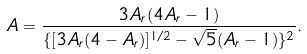<formula> <loc_0><loc_0><loc_500><loc_500>A = \frac { 3 A _ { r } ( 4 A _ { r } - 1 ) } { \{ [ 3 A _ { r } ( 4 - A _ { r } ) ] ^ { 1 / 2 } - \sqrt { 5 } ( A _ { r } - 1 ) \} ^ { 2 } } .</formula> 